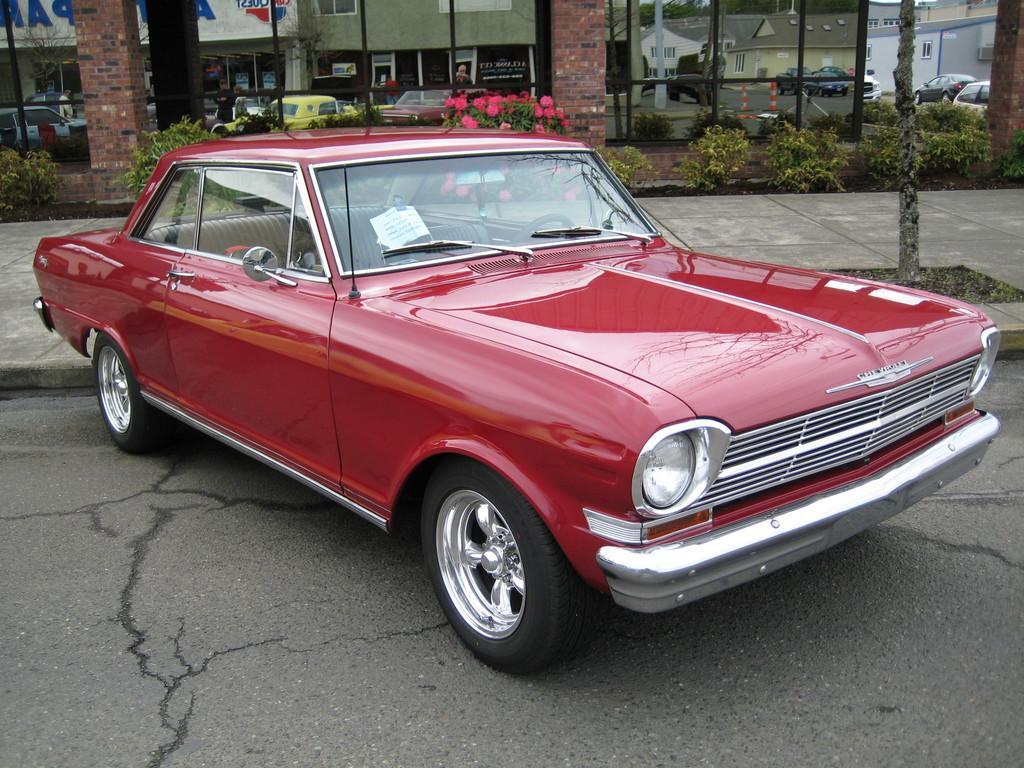In one or two sentences, can you explain what this image depicts? There is a red color car on the road. In the background we can see plants, pillars, vehicles, and flowers. On the glass we can see the reflection of buildings. 